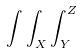Convert formula to latex. <formula><loc_0><loc_0><loc_500><loc_500>\int \int _ { X } \int _ { Y } ^ { Z }</formula> 